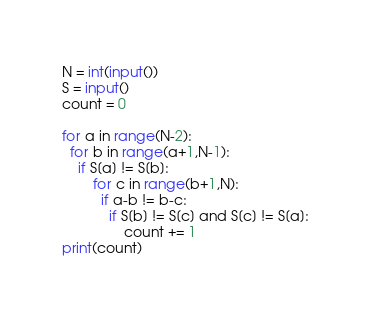Convert code to text. <code><loc_0><loc_0><loc_500><loc_500><_Python_>N = int(input())
S = input()
count = 0

for a in range(N-2):
  for b in range(a+1,N-1):
    if S[a] != S[b]:
        for c in range(b+1,N):
          if a-b != b-c:
            if S[b] != S[c] and S[c] != S[a]:
                count += 1
print(count)</code> 